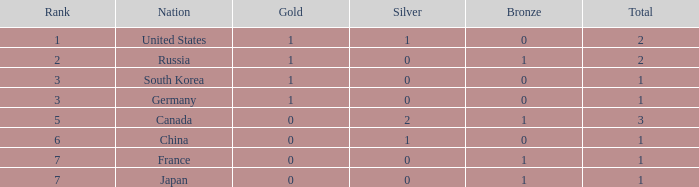Which Bronze has a Rank of 3, and a Silver larger than 0? None. 